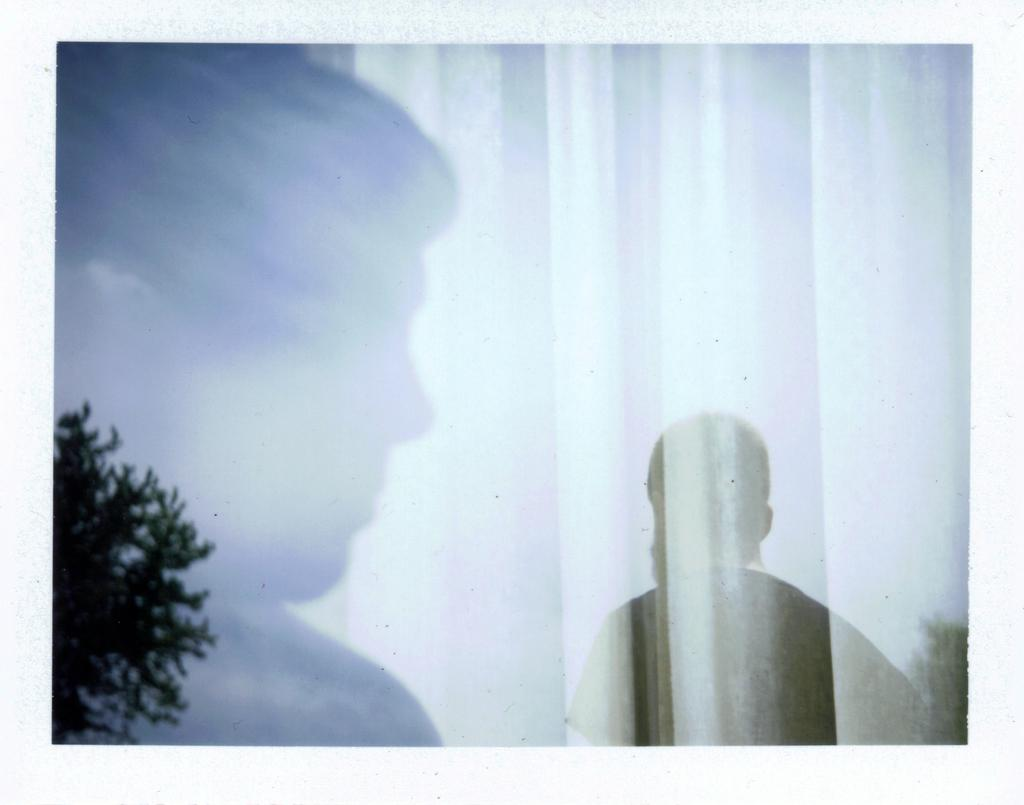What can be seen on the left side of the image? There is a shadow of a person and a shadow of a tree on the left side of the image. Can you describe the shadows in the image? Yes, there is a shadow of a person and a shadow of a tree on the left side of the image. Are the shadows on the ground or on a surface? The shadows are on the ground in the image. What type of branch can be seen in the image? There is no branch present in the image; only the shadows of a person and a tree are visible. What year is depicted in the image? The image does not depict a specific year; it only shows shadows of a person and a tree. 